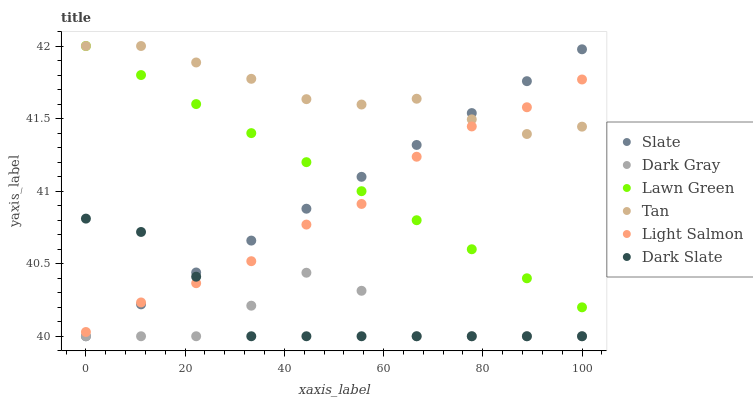Does Dark Gray have the minimum area under the curve?
Answer yes or no. Yes. Does Tan have the maximum area under the curve?
Answer yes or no. Yes. Does Light Salmon have the minimum area under the curve?
Answer yes or no. No. Does Light Salmon have the maximum area under the curve?
Answer yes or no. No. Is Lawn Green the smoothest?
Answer yes or no. Yes. Is Dark Gray the roughest?
Answer yes or no. Yes. Is Light Salmon the smoothest?
Answer yes or no. No. Is Light Salmon the roughest?
Answer yes or no. No. Does Slate have the lowest value?
Answer yes or no. Yes. Does Light Salmon have the lowest value?
Answer yes or no. No. Does Tan have the highest value?
Answer yes or no. Yes. Does Light Salmon have the highest value?
Answer yes or no. No. Is Dark Gray less than Light Salmon?
Answer yes or no. Yes. Is Light Salmon greater than Dark Gray?
Answer yes or no. Yes. Does Light Salmon intersect Tan?
Answer yes or no. Yes. Is Light Salmon less than Tan?
Answer yes or no. No. Is Light Salmon greater than Tan?
Answer yes or no. No. Does Dark Gray intersect Light Salmon?
Answer yes or no. No. 